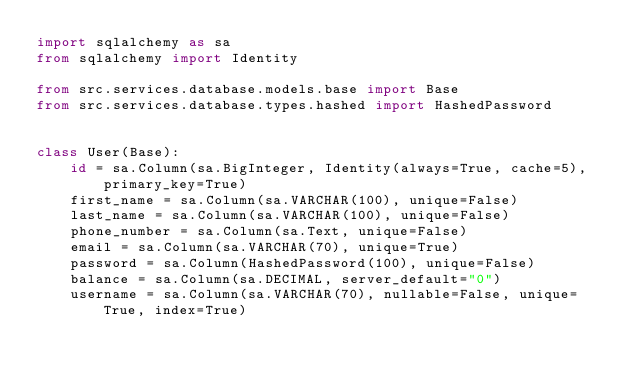<code> <loc_0><loc_0><loc_500><loc_500><_Python_>import sqlalchemy as sa
from sqlalchemy import Identity

from src.services.database.models.base import Base
from src.services.database.types.hashed import HashedPassword


class User(Base):
    id = sa.Column(sa.BigInteger, Identity(always=True, cache=5), primary_key=True)
    first_name = sa.Column(sa.VARCHAR(100), unique=False)
    last_name = sa.Column(sa.VARCHAR(100), unique=False)
    phone_number = sa.Column(sa.Text, unique=False)
    email = sa.Column(sa.VARCHAR(70), unique=True)
    password = sa.Column(HashedPassword(100), unique=False)
    balance = sa.Column(sa.DECIMAL, server_default="0")
    username = sa.Column(sa.VARCHAR(70), nullable=False, unique=True, index=True)
</code> 